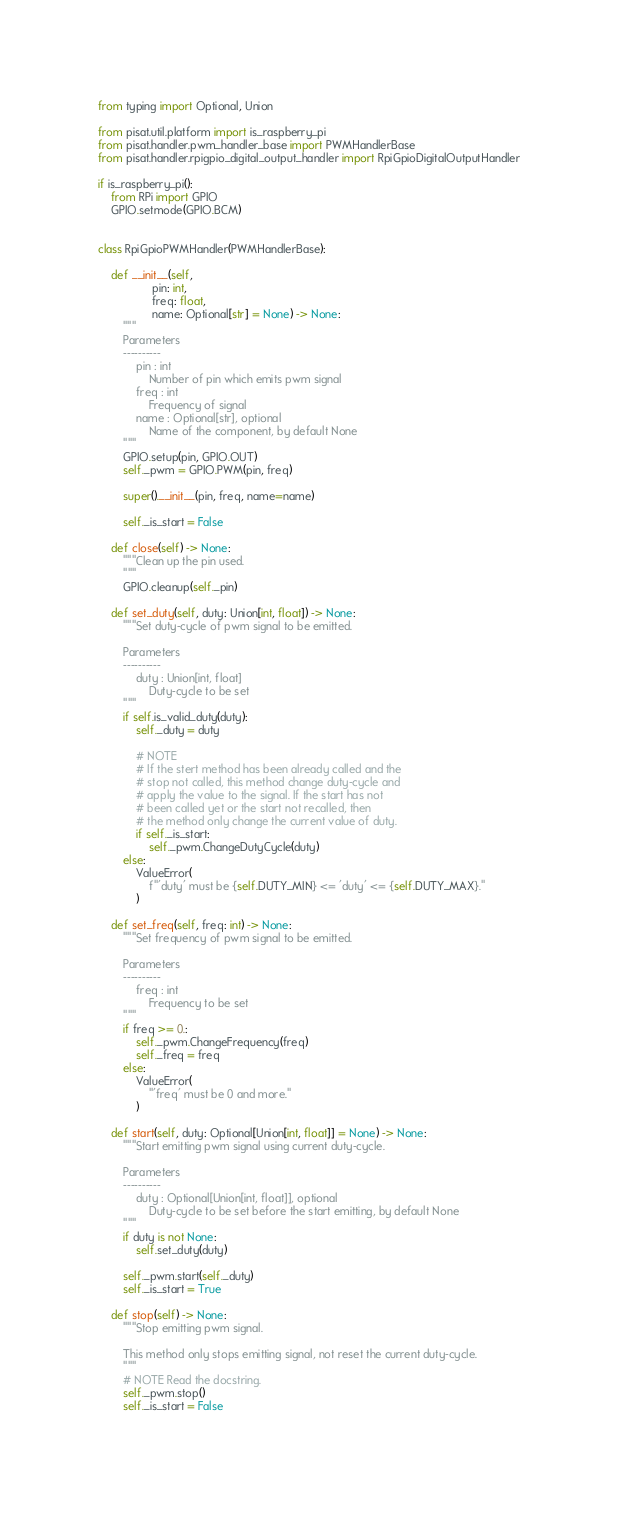Convert code to text. <code><loc_0><loc_0><loc_500><loc_500><_Python_>
from typing import Optional, Union

from pisat.util.platform import is_raspberry_pi
from pisat.handler.pwm_handler_base import PWMHandlerBase
from pisat.handler.rpigpio_digital_output_handler import RpiGpioDigitalOutputHandler

if is_raspberry_pi():
    from RPi import GPIO
    GPIO.setmode(GPIO.BCM)
    

class RpiGpioPWMHandler(PWMHandlerBase):            
    
    def __init__(self, 
                 pin: int, 
                 freq: float,
                 name: Optional[str] = None) -> None:
        """
        Parameters
        ----------
            pin : int
                Number of pin which emits pwm signal
            freq : int
                Frequency of signal
            name : Optional[str], optional
                Name of the component, by default None
        """
        GPIO.setup(pin, GPIO.OUT)
        self._pwm = GPIO.PWM(pin, freq)
        
        super().__init__(pin, freq, name=name)
        
        self._is_start = False
        
    def close(self) -> None:
        """Clean up the pin used.
        """
        GPIO.cleanup(self._pin)
        
    def set_duty(self, duty: Union[int, float]) -> None:
        """Set duty-cycle of pwm signal to be emitted.

        Parameters
        ----------
            duty : Union[int, float]
                Duty-cycle to be set
        """
        if self.is_valid_duty(duty):
            self._duty = duty
            
            # NOTE
            # If the stert method has been already called and the 
            # stop not called, this method change duty-cycle and
            # apply the value to the signal. If the start has not
            # been called yet or the start not recalled, then
            # the method only change the current value of duty.
            if self._is_start:
                self._pwm.ChangeDutyCycle(duty)
        else:
            ValueError(
                f"'duty' must be {self.DUTY_MIN} <= 'duty' <= {self.DUTY_MAX}."
            )
        
    def set_freq(self, freq: int) -> None:
        """Set frequency of pwm signal to be emitted.

        Parameters
        ----------
            freq : int
                Frequency to be set
        """
        if freq >= 0.:
            self._pwm.ChangeFrequency(freq)
            self._freq = freq
        else:
            ValueError(
                "'freq' must be 0 and more."
            )
            
    def start(self, duty: Optional[Union[int, float]] = None) -> None:
        """Start emitting pwm signal using current duty-cycle.

        Parameters
        ----------
            duty : Optional[Union[int, float]], optional
                Duty-cycle to be set before the start emitting, by default None
        """
        if duty is not None:
            self.set_duty(duty)
            
        self._pwm.start(self._duty)
        self._is_start = True
        
    def stop(self) -> None:
        """Stop emitting pwm signal.
        
        This method only stops emitting signal, not reset the current duty-cycle.
        """
        # NOTE Read the docstring.
        self._pwm.stop()
        self._is_start = False
            </code> 